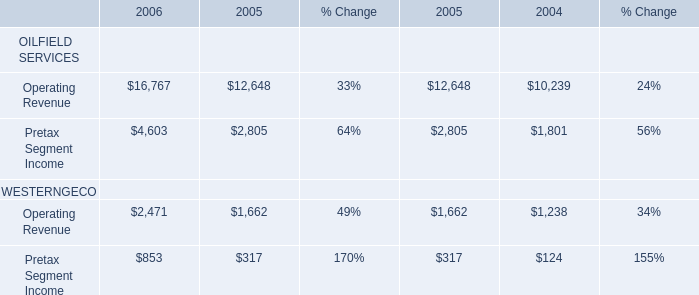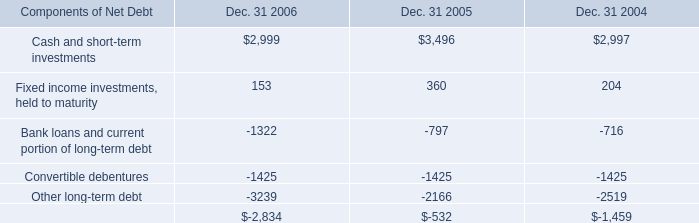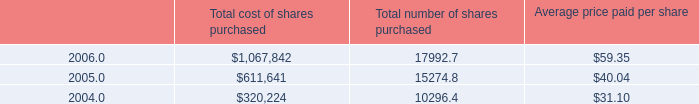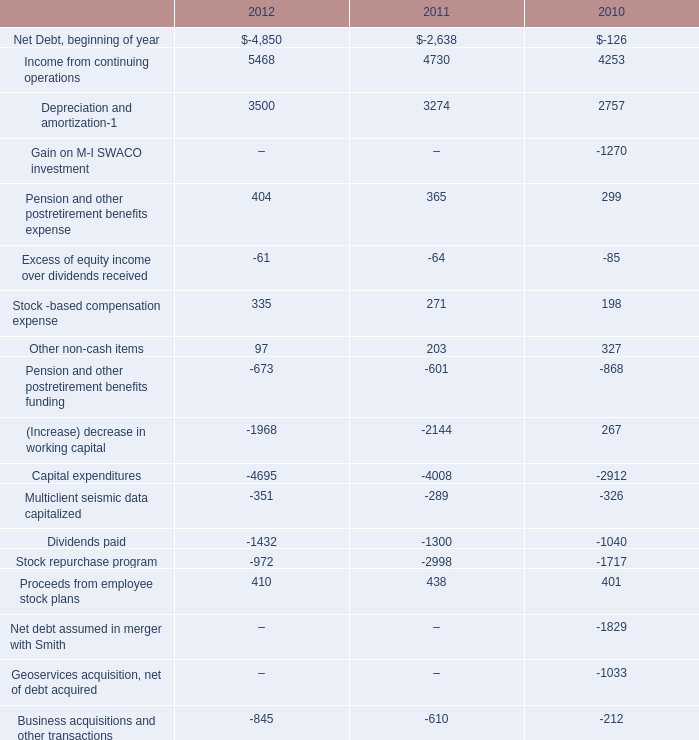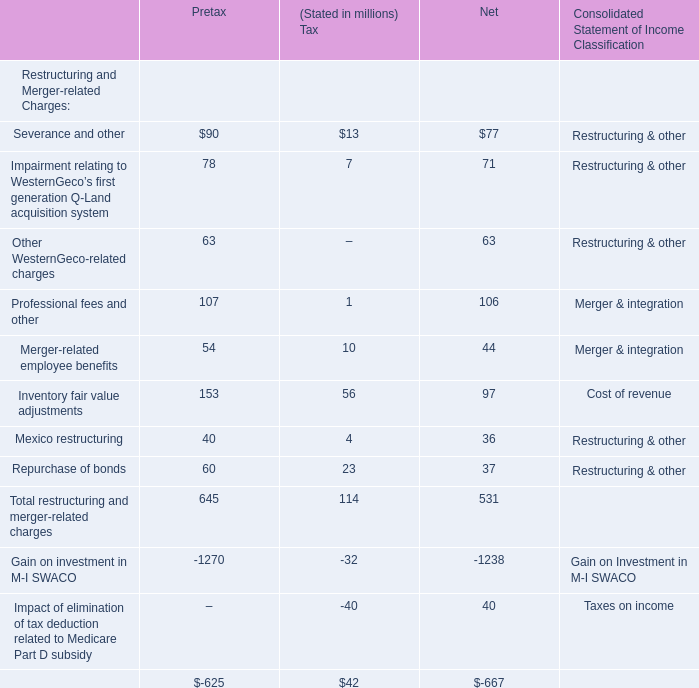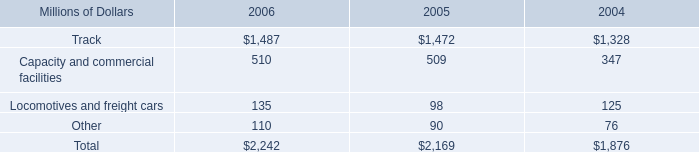For the kind of Restructuring and Merger-related Charges where the Net Income is larger than 100 million, what's the Pretax Income? (in million) 
Answer: 107. 